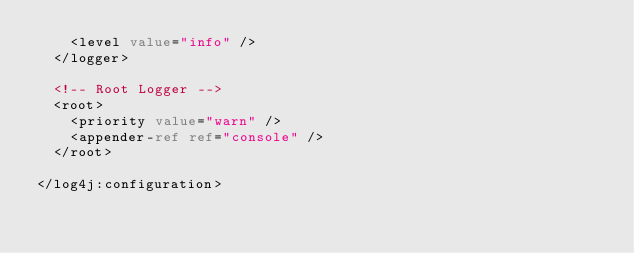Convert code to text. <code><loc_0><loc_0><loc_500><loc_500><_XML_>		<level value="info" />
	</logger>

	<!-- Root Logger -->
	<root>
		<priority value="warn" />
		<appender-ref ref="console" />
	</root>
	
</log4j:configuration>
</code> 